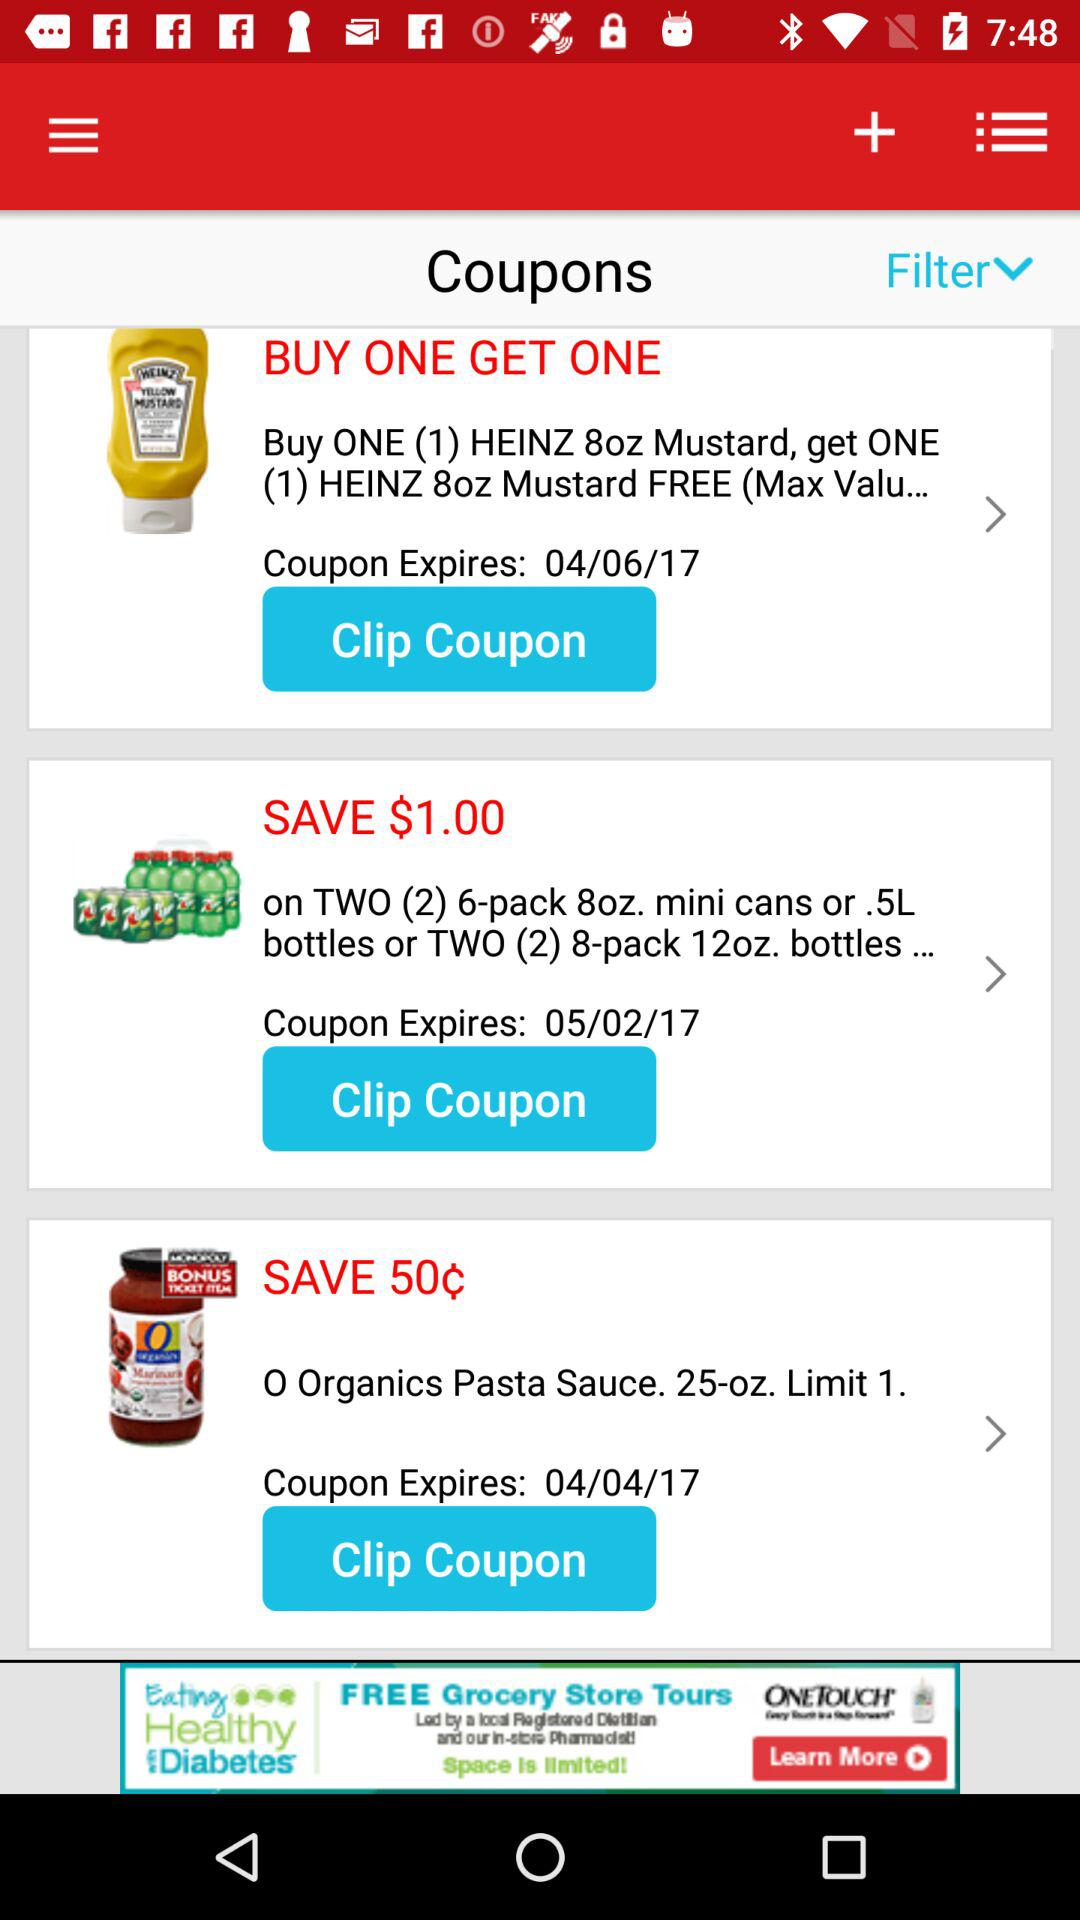When will the coupon for "O Organics Pasta Sauce" expire? The coupon will expire on April 4, 2017. 